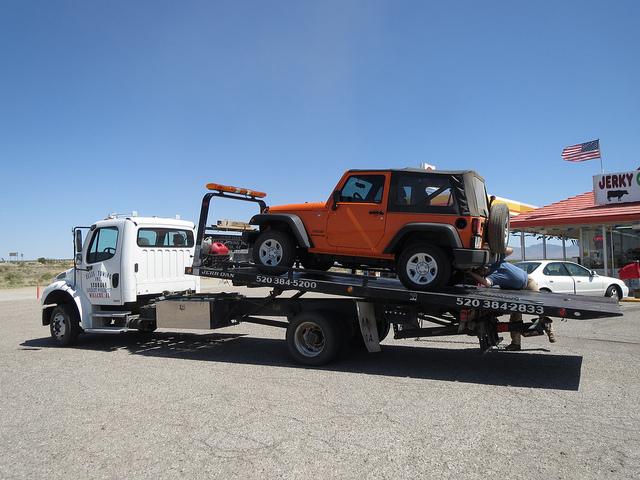What letters are on the side of the building?
Answer briefly. Jerky. What is the road made out of?
Answer briefly. Asphalt. How many cars are there?
Keep it brief. 2. What color is the jeep?
Keep it brief. Orange. What business uses the truck?
Quick response, please. Towing. How many wheels on the truck?
Write a very short answer. 4. What is on the truck?
Give a very brief answer. Jeep. What is on the back of the flatbed?
Quick response, please. Jeep. Which vehicle is doing the hauling?
Answer briefly. Tow truck. Why a tow?
Answer briefly. Car broke. 